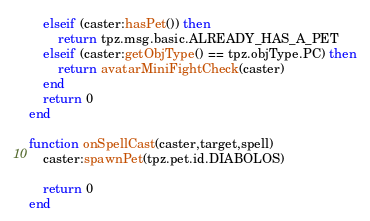<code> <loc_0><loc_0><loc_500><loc_500><_Lua_>    elseif (caster:hasPet()) then
        return tpz.msg.basic.ALREADY_HAS_A_PET
    elseif (caster:getObjType() == tpz.objType.PC) then
        return avatarMiniFightCheck(caster)
    end
    return 0
end

function onSpellCast(caster,target,spell)
    caster:spawnPet(tpz.pet.id.DIABOLOS)

    return 0
end
</code> 